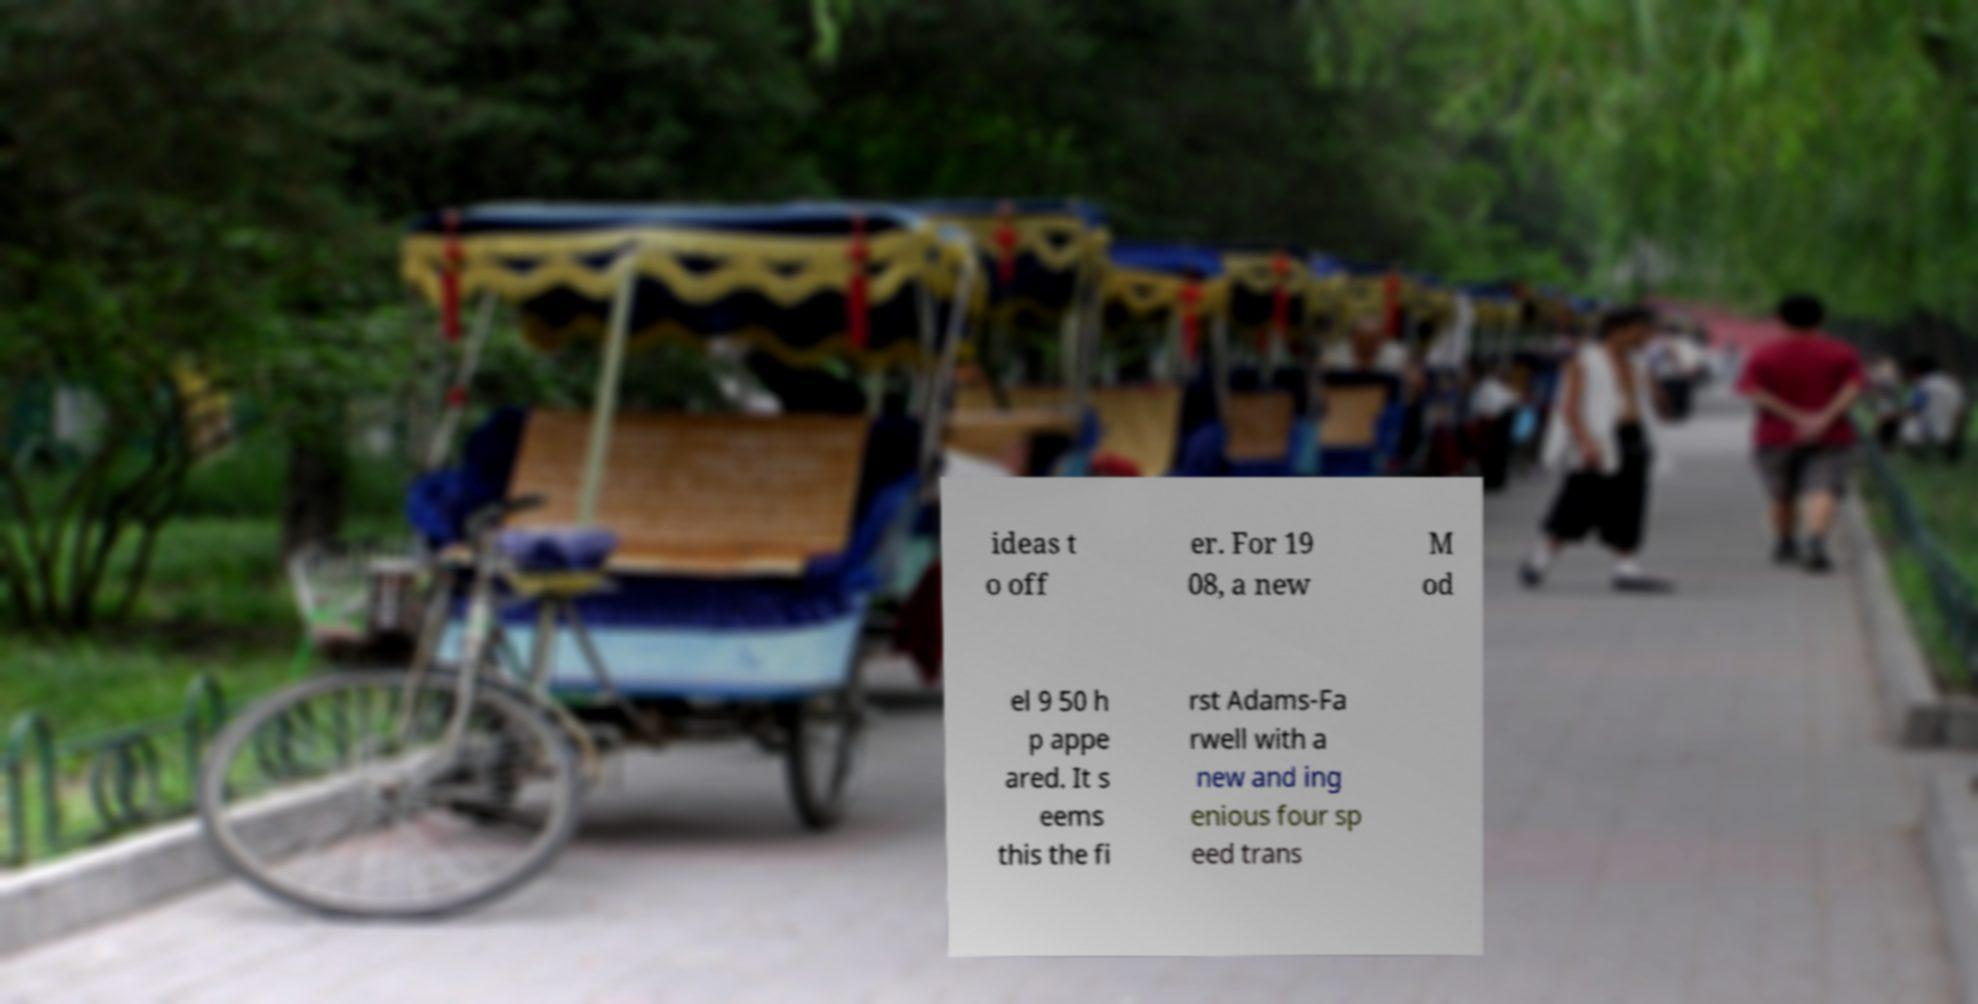Could you assist in decoding the text presented in this image and type it out clearly? ideas t o off er. For 19 08, a new M od el 9 50 h p appe ared. It s eems this the fi rst Adams-Fa rwell with a new and ing enious four sp eed trans 